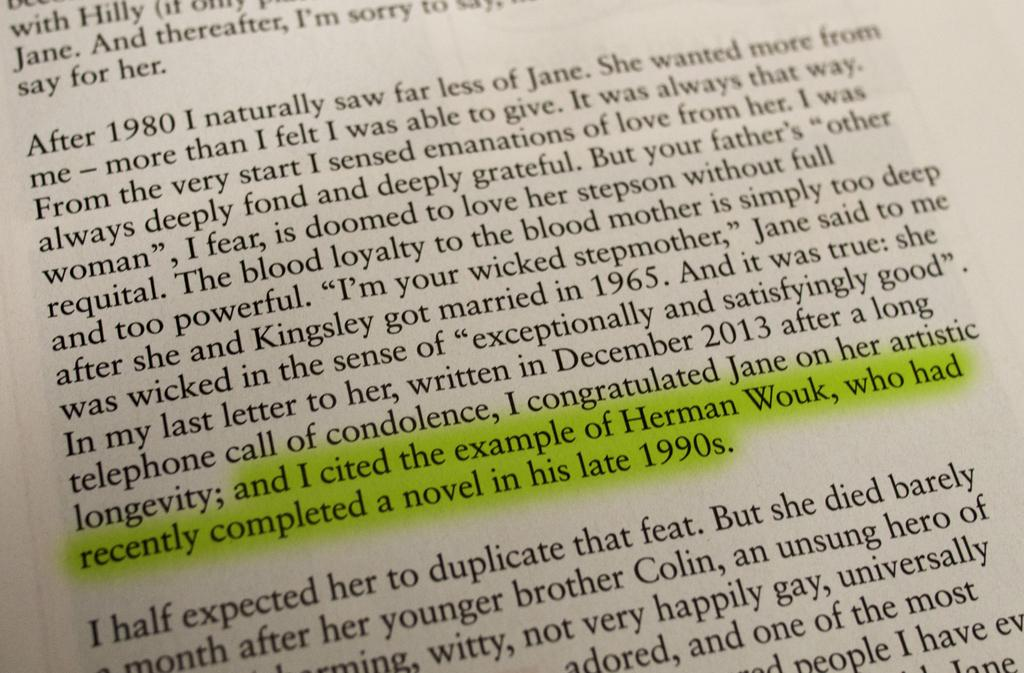<image>
Provide a brief description of the given image. A page from a book with a highlighted selection that includes the words "...and I cited the example of Herman Wouk...". 